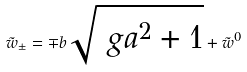<formula> <loc_0><loc_0><loc_500><loc_500>\tilde { w } _ { \pm } = \mp b \sqrt { \ g a ^ { 2 } + 1 } + \tilde { w } ^ { 0 }</formula> 